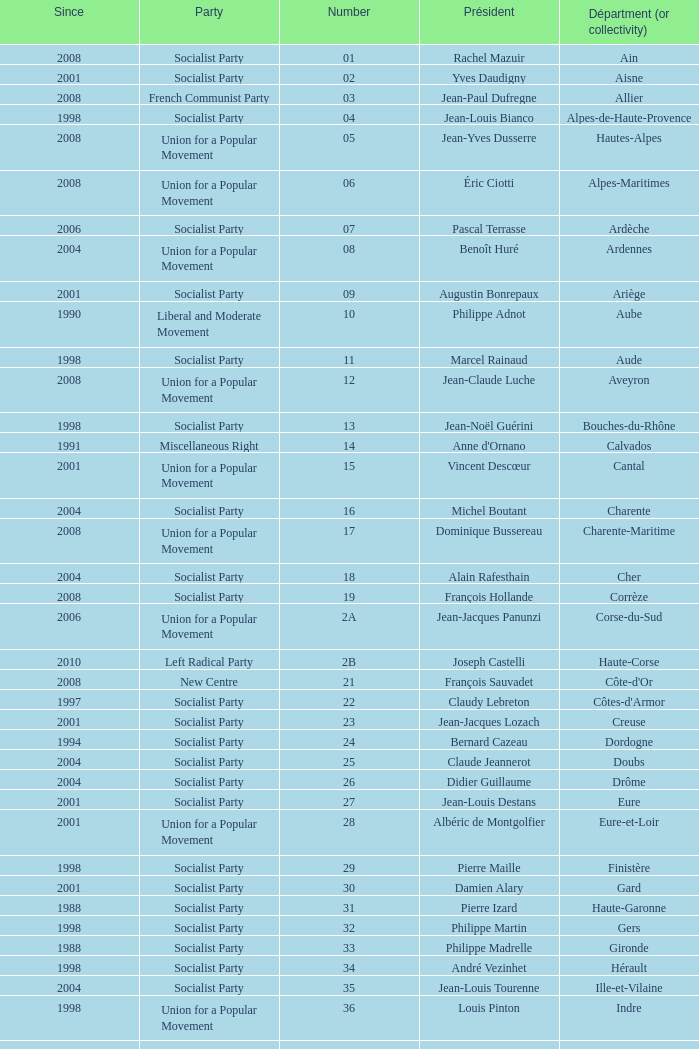What number corresponds to Presidet Yves Krattinger of the Socialist party? 70.0. 